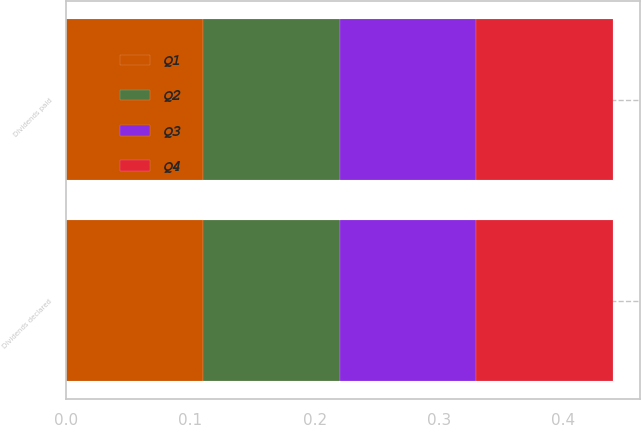Convert chart to OTSL. <chart><loc_0><loc_0><loc_500><loc_500><stacked_bar_chart><ecel><fcel>Dividends declared<fcel>Dividends paid<nl><fcel>Q4<fcel>0.11<fcel>0.11<nl><fcel>Q1<fcel>0.11<fcel>0.11<nl><fcel>Q3<fcel>0.11<fcel>0.11<nl><fcel>Q2<fcel>0.11<fcel>0.11<nl></chart> 